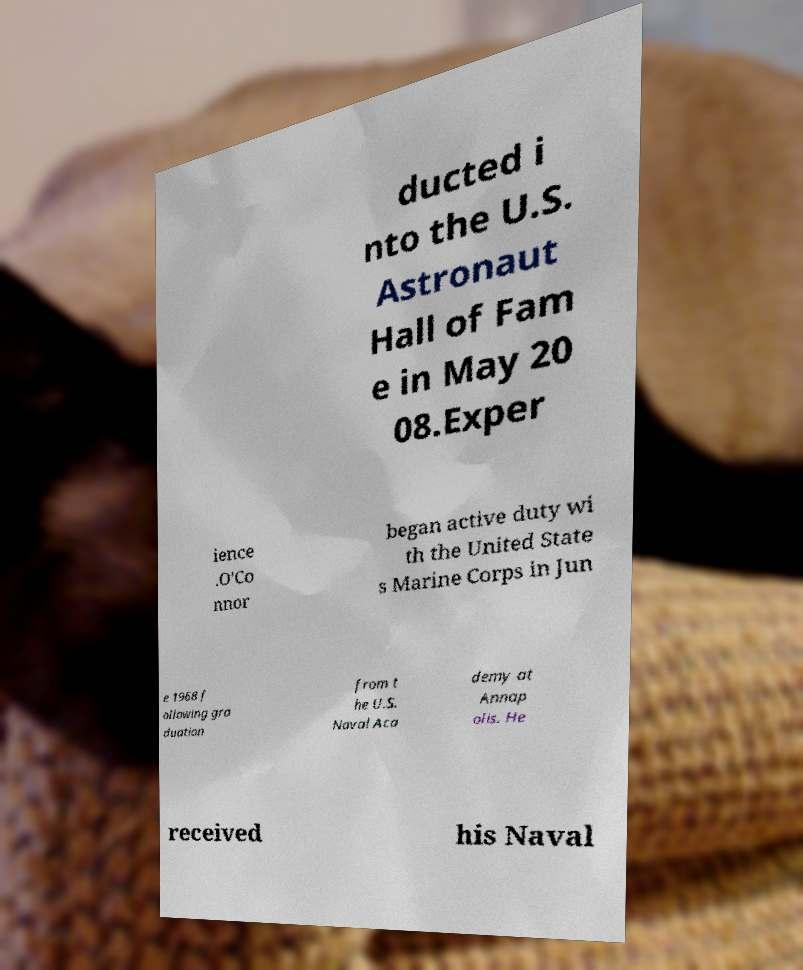Please identify and transcribe the text found in this image. ducted i nto the U.S. Astronaut Hall of Fam e in May 20 08.Exper ience .O'Co nnor began active duty wi th the United State s Marine Corps in Jun e 1968 f ollowing gra duation from t he U.S. Naval Aca demy at Annap olis. He received his Naval 